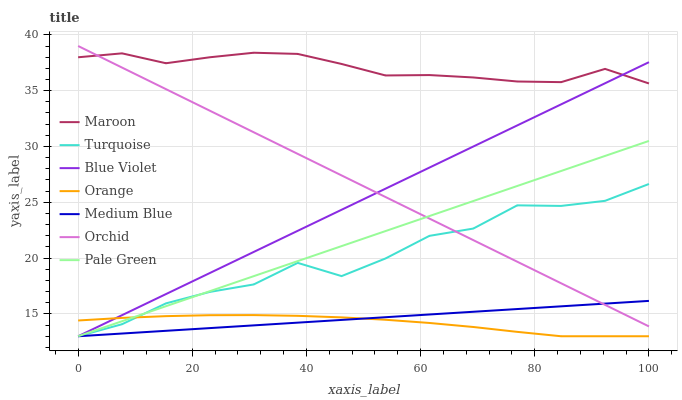Does Orange have the minimum area under the curve?
Answer yes or no. Yes. Does Maroon have the maximum area under the curve?
Answer yes or no. Yes. Does Medium Blue have the minimum area under the curve?
Answer yes or no. No. Does Medium Blue have the maximum area under the curve?
Answer yes or no. No. Is Orchid the smoothest?
Answer yes or no. Yes. Is Turquoise the roughest?
Answer yes or no. Yes. Is Medium Blue the smoothest?
Answer yes or no. No. Is Medium Blue the roughest?
Answer yes or no. No. Does Turquoise have the lowest value?
Answer yes or no. Yes. Does Maroon have the lowest value?
Answer yes or no. No. Does Orchid have the highest value?
Answer yes or no. Yes. Does Medium Blue have the highest value?
Answer yes or no. No. Is Orange less than Orchid?
Answer yes or no. Yes. Is Maroon greater than Turquoise?
Answer yes or no. Yes. Does Blue Violet intersect Maroon?
Answer yes or no. Yes. Is Blue Violet less than Maroon?
Answer yes or no. No. Is Blue Violet greater than Maroon?
Answer yes or no. No. Does Orange intersect Orchid?
Answer yes or no. No. 